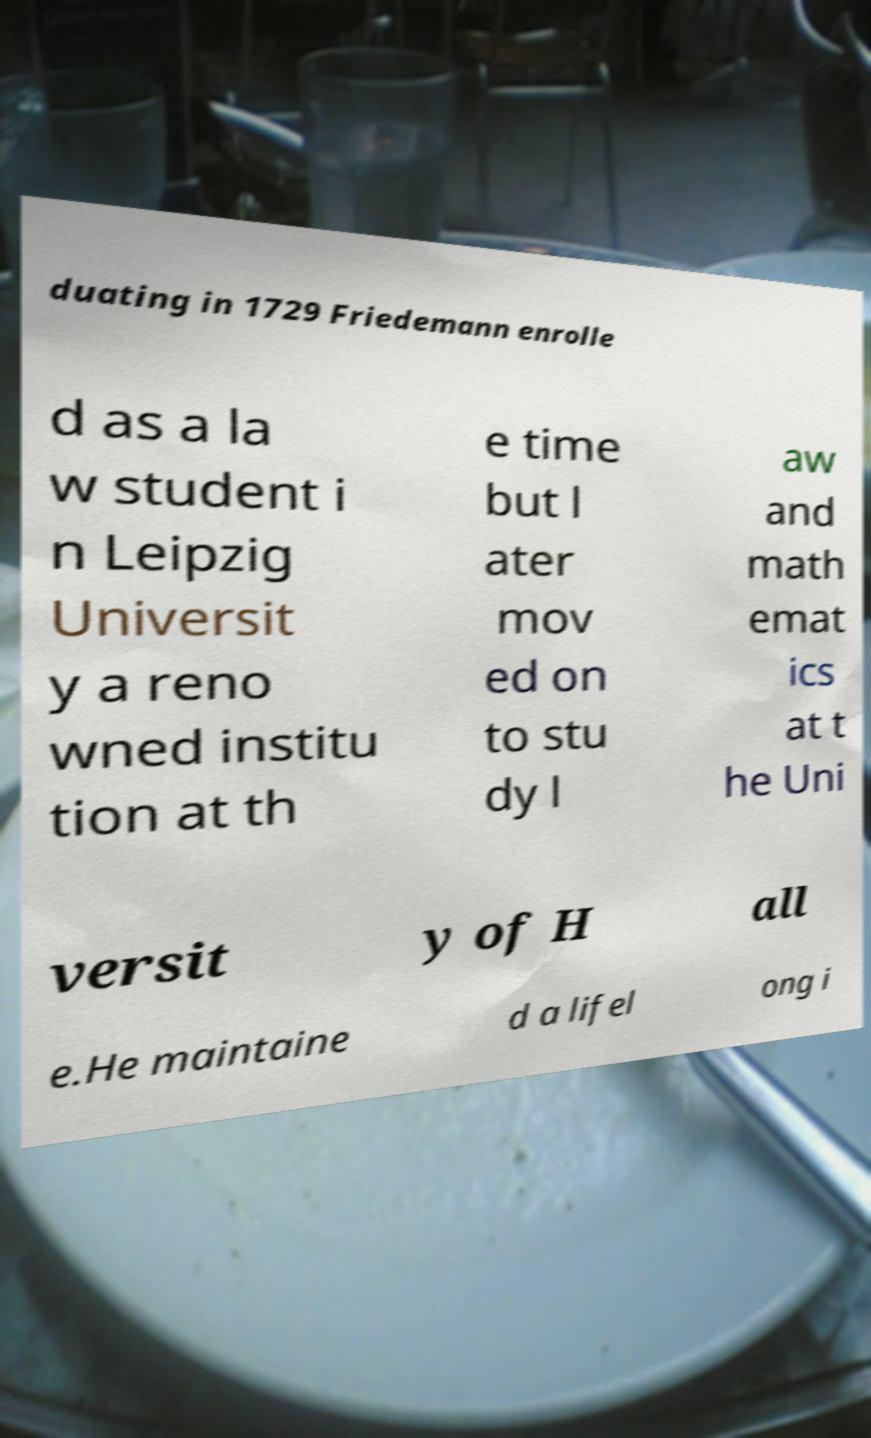Can you accurately transcribe the text from the provided image for me? duating in 1729 Friedemann enrolle d as a la w student i n Leipzig Universit y a reno wned institu tion at th e time but l ater mov ed on to stu dy l aw and math emat ics at t he Uni versit y of H all e.He maintaine d a lifel ong i 